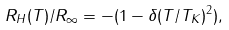Convert formula to latex. <formula><loc_0><loc_0><loc_500><loc_500>R _ { H } ( T ) / R _ { \infty } = - ( 1 - \delta ( T / T _ { K } ) ^ { 2 } ) ,</formula> 